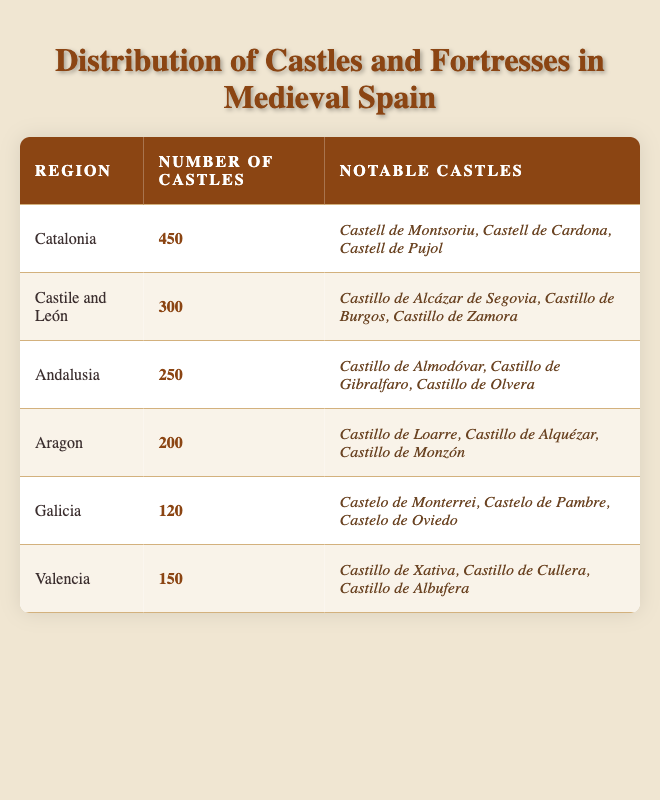What region has the highest number of castles? According to the table, Catalonia has the highest number of castles, totaling 450.
Answer: Catalonia How many notable castles are listed for Andalusia? In the table, Andalusia lists three notable castles: Castillo de Almodóvar, Castillo de Gibralfaro, and Castillo de Olvera.
Answer: Three What is the total number of castles in Castile and León and Aragon combined? To find the total, we add the number of castles in Castile and León (300) to the number in Aragon (200): 300 + 200 = 500.
Answer: 500 Is there a region with more than 200 castles that is not Catalonia? Yes, Castile and León has 300 castles and Andalusia has 250, both of which are more than 200.
Answer: Yes Which region has the fewest number of castles? From the table, Galicia has the fewest number of castles listed, with a total of 120.
Answer: Galicia What is the average number of castles across all listed regions? To calculate the average, we sum all castles: 450 + 300 + 250 + 200 + 120 + 150 = 1470. There are 6 regions, so the average is 1470 / 6 = 245.
Answer: 245 Are there more notable castles in Catalonia or Valencia? Catalonia lists three notable castles (Castell de Montsoriu, Castell de Cardona, Castell de Pujol), while Valencia also lists three notable castles (Castillo de Xativa, Castillo de Cullera, Castillo de Albufera). Therefore, both regions have the same number of notable castles.
Answer: No What is the difference in the number of castles between Castile and León and Valencia? Castile and León has 300 castles, while Valencia has 150. To find the difference, we subtract: 300 - 150 = 150.
Answer: 150 Which region has notable castles with the name "Castillo" in their titles? Andalusia, Castile and León, and Aragon all have notable castles including "Castillo" in their titles. The notable castles are Castillo de Almodóvar and Castillo de Gibralfaro for Andalusia, Castillo de Alcázar de Segovia and Castillo de Burgos for Castile and León, and Castillo de Loarre and Castillo de Alquézar for Aragon.
Answer: Yes 